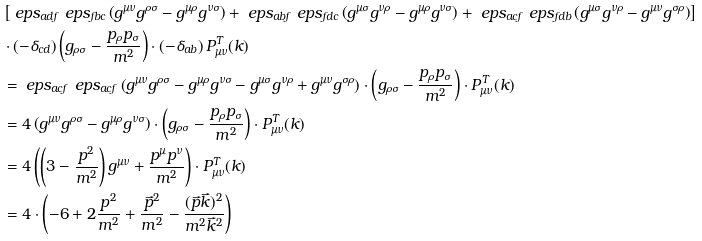<formula> <loc_0><loc_0><loc_500><loc_500>& \left [ \ e p s _ { a d f } \ e p s _ { f b c } \left ( g ^ { \mu \nu } g ^ { \rho \sigma } - g ^ { \mu \rho } g ^ { \nu \sigma } \right ) + \ e p s _ { a b f } \ e p s _ { f d c } \left ( g ^ { \mu \sigma } g ^ { \nu \rho } - g ^ { \mu \rho } g ^ { \nu \sigma } \right ) + \ e p s _ { a c f } \ e p s _ { f d b } \left ( g ^ { \mu \sigma } g ^ { \nu \rho } - g ^ { \mu \nu } g ^ { \sigma \rho } \right ) \right ] \\ & \cdot \left ( - \delta _ { c d } \right ) \left ( g _ { \rho \sigma } - \frac { p _ { \rho } p _ { \sigma } } { m ^ { 2 } } \right ) \cdot \left ( - \delta _ { a b } \right ) P ^ { T } _ { \mu \nu } ( k ) \\ & = \ e p s _ { a c f } \ e p s _ { a c f } \left ( g ^ { \mu \nu } g ^ { \rho \sigma } - g ^ { \mu \rho } g ^ { \nu \sigma } - g ^ { \mu \sigma } g ^ { \nu \rho } + g ^ { \mu \nu } g ^ { \sigma \rho } \right ) \cdot \left ( g _ { \rho \sigma } - \frac { p _ { \rho } p _ { \sigma } } { m ^ { 2 } } \right ) \cdot P ^ { T } _ { \mu \nu } ( k ) \\ & = 4 \left ( g ^ { \mu \nu } g ^ { \rho \sigma } - g ^ { \mu \rho } g ^ { \nu \sigma } \right ) \cdot \left ( g _ { \rho \sigma } - \frac { p _ { \rho } p _ { \sigma } } { m ^ { 2 } } \right ) \cdot P ^ { T } _ { \mu \nu } ( k ) \\ & = 4 \left ( \left ( 3 - \frac { p ^ { 2 } } { m ^ { 2 } } \right ) g ^ { \mu \nu } + \frac { p ^ { \mu } p ^ { \nu } } { m ^ { 2 } } \right ) \cdot P _ { \mu \nu } ^ { T } ( k ) \\ & = 4 \cdot \left ( - 6 + 2 \frac { p ^ { 2 } } { m ^ { 2 } } + \frac { \vec { p } ^ { 2 } } { m ^ { 2 } } - \frac { ( \vec { p } \vec { k } ) ^ { 2 } } { m ^ { 2 } \vec { k } ^ { 2 } } \right )</formula> 